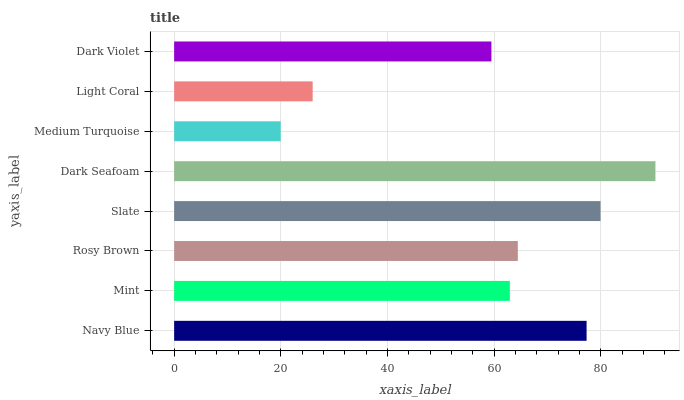Is Medium Turquoise the minimum?
Answer yes or no. Yes. Is Dark Seafoam the maximum?
Answer yes or no. Yes. Is Mint the minimum?
Answer yes or no. No. Is Mint the maximum?
Answer yes or no. No. Is Navy Blue greater than Mint?
Answer yes or no. Yes. Is Mint less than Navy Blue?
Answer yes or no. Yes. Is Mint greater than Navy Blue?
Answer yes or no. No. Is Navy Blue less than Mint?
Answer yes or no. No. Is Rosy Brown the high median?
Answer yes or no. Yes. Is Mint the low median?
Answer yes or no. Yes. Is Medium Turquoise the high median?
Answer yes or no. No. Is Rosy Brown the low median?
Answer yes or no. No. 